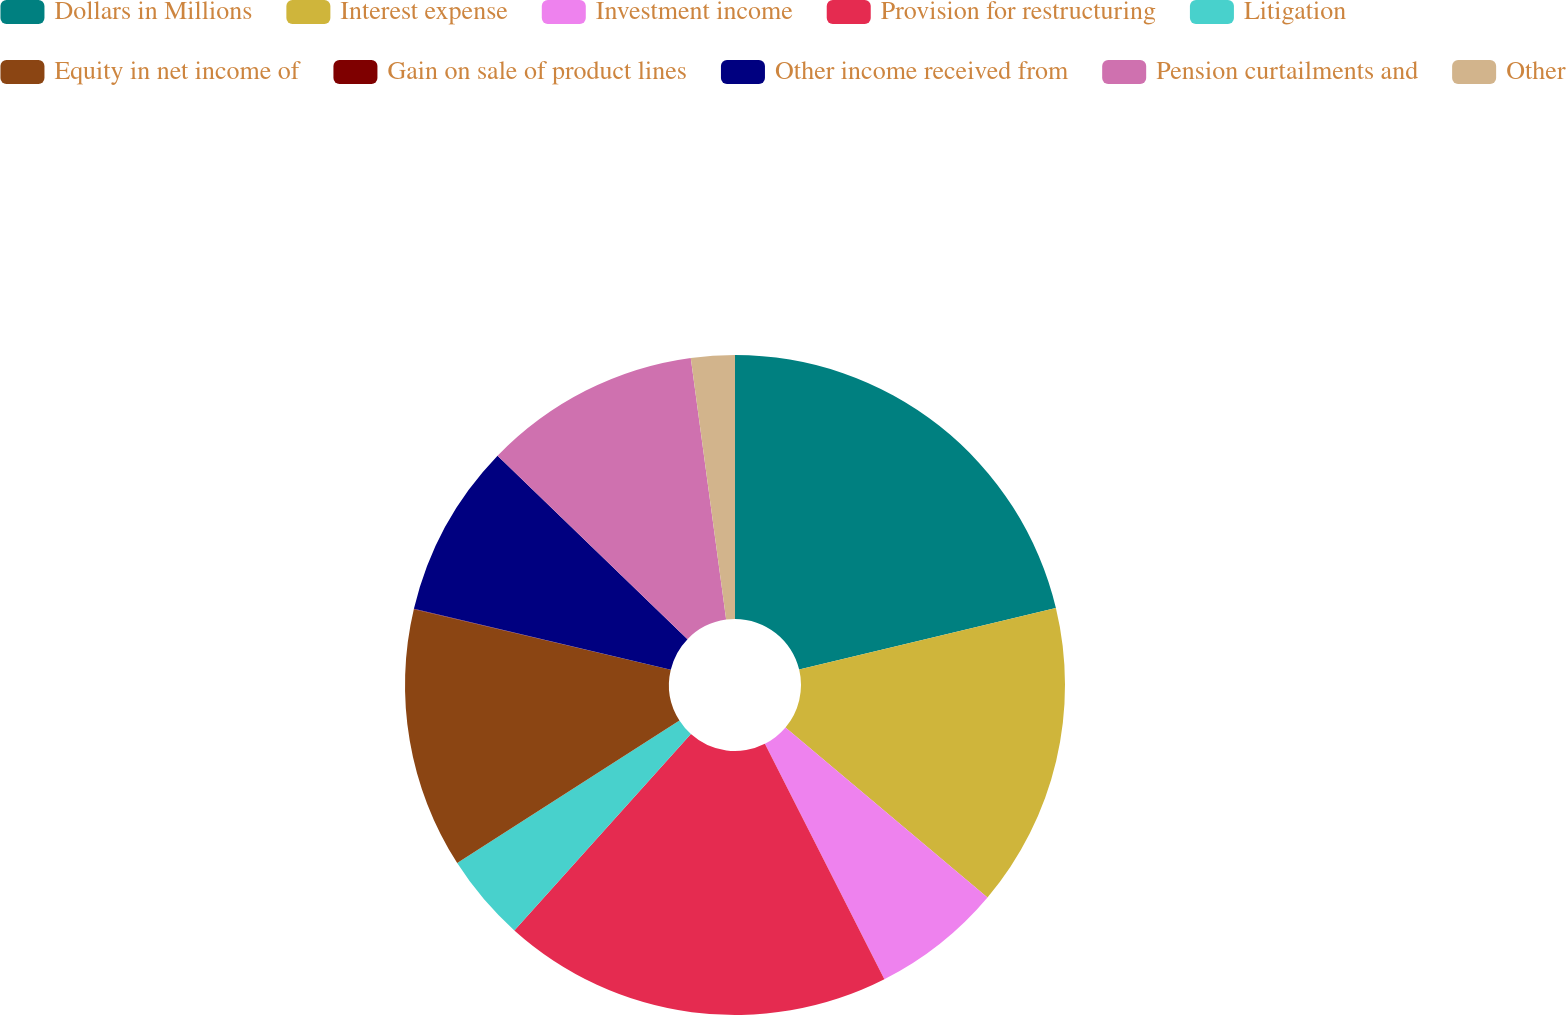Convert chart. <chart><loc_0><loc_0><loc_500><loc_500><pie_chart><fcel>Dollars in Millions<fcel>Interest expense<fcel>Investment income<fcel>Provision for restructuring<fcel>Litigation<fcel>Equity in net income of<fcel>Gain on sale of product lines<fcel>Other income received from<fcel>Pension curtailments and<fcel>Other<nl><fcel>21.25%<fcel>14.88%<fcel>6.39%<fcel>19.13%<fcel>4.27%<fcel>12.76%<fcel>0.02%<fcel>8.51%<fcel>10.64%<fcel>2.14%<nl></chart> 